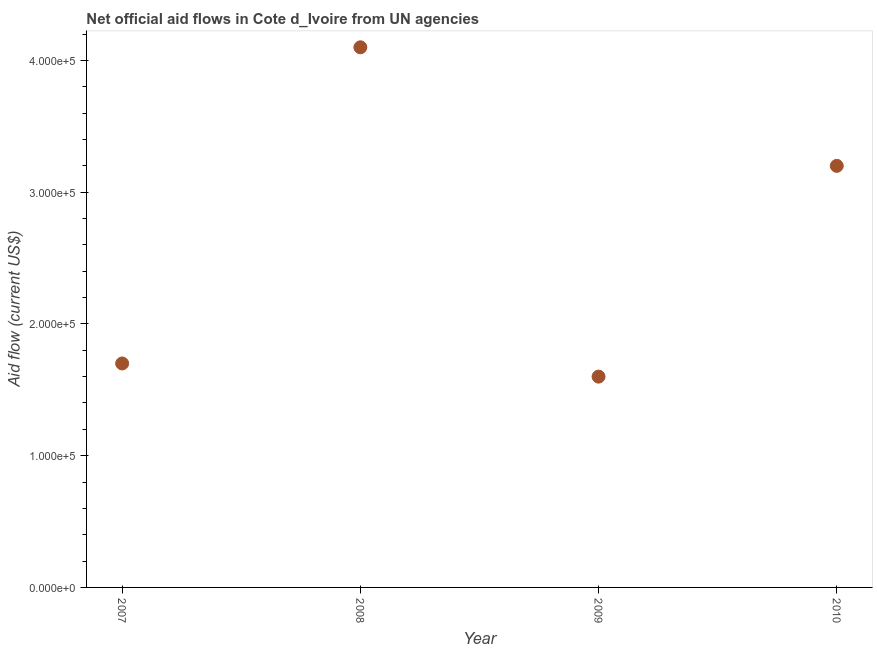What is the net official flows from un agencies in 2008?
Keep it short and to the point. 4.10e+05. Across all years, what is the maximum net official flows from un agencies?
Make the answer very short. 4.10e+05. Across all years, what is the minimum net official flows from un agencies?
Your response must be concise. 1.60e+05. In which year was the net official flows from un agencies maximum?
Provide a short and direct response. 2008. What is the sum of the net official flows from un agencies?
Your response must be concise. 1.06e+06. What is the difference between the net official flows from un agencies in 2008 and 2009?
Your answer should be very brief. 2.50e+05. What is the average net official flows from un agencies per year?
Your response must be concise. 2.65e+05. What is the median net official flows from un agencies?
Provide a short and direct response. 2.45e+05. What is the ratio of the net official flows from un agencies in 2007 to that in 2008?
Make the answer very short. 0.41. Is the difference between the net official flows from un agencies in 2007 and 2009 greater than the difference between any two years?
Your answer should be very brief. No. What is the difference between the highest and the lowest net official flows from un agencies?
Ensure brevity in your answer.  2.50e+05. Does the net official flows from un agencies monotonically increase over the years?
Provide a short and direct response. No. What is the difference between two consecutive major ticks on the Y-axis?
Your answer should be very brief. 1.00e+05. Are the values on the major ticks of Y-axis written in scientific E-notation?
Keep it short and to the point. Yes. Does the graph contain any zero values?
Ensure brevity in your answer.  No. Does the graph contain grids?
Make the answer very short. No. What is the title of the graph?
Provide a short and direct response. Net official aid flows in Cote d_Ivoire from UN agencies. What is the label or title of the X-axis?
Your answer should be compact. Year. What is the label or title of the Y-axis?
Provide a short and direct response. Aid flow (current US$). What is the Aid flow (current US$) in 2009?
Your answer should be compact. 1.60e+05. What is the difference between the Aid flow (current US$) in 2008 and 2009?
Offer a very short reply. 2.50e+05. What is the difference between the Aid flow (current US$) in 2009 and 2010?
Keep it short and to the point. -1.60e+05. What is the ratio of the Aid flow (current US$) in 2007 to that in 2008?
Provide a succinct answer. 0.41. What is the ratio of the Aid flow (current US$) in 2007 to that in 2009?
Your response must be concise. 1.06. What is the ratio of the Aid flow (current US$) in 2007 to that in 2010?
Ensure brevity in your answer.  0.53. What is the ratio of the Aid flow (current US$) in 2008 to that in 2009?
Your answer should be very brief. 2.56. What is the ratio of the Aid flow (current US$) in 2008 to that in 2010?
Provide a short and direct response. 1.28. 